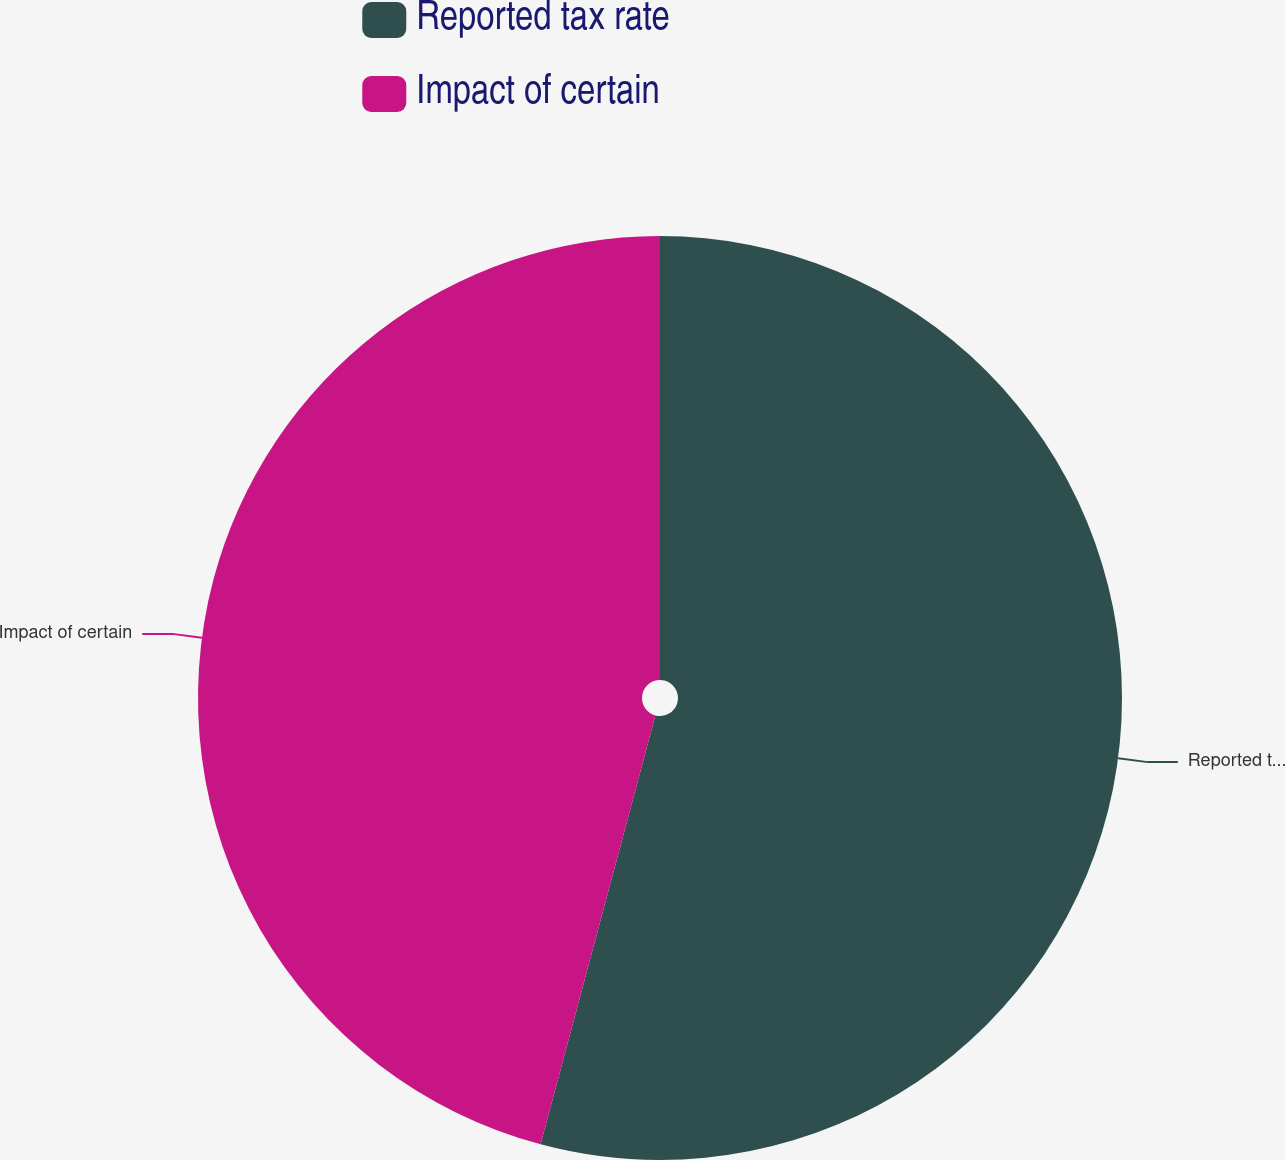Convert chart. <chart><loc_0><loc_0><loc_500><loc_500><pie_chart><fcel>Reported tax rate<fcel>Impact of certain<nl><fcel>54.16%<fcel>45.84%<nl></chart> 